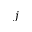Convert formula to latex. <formula><loc_0><loc_0><loc_500><loc_500>j</formula> 